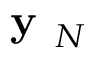<formula> <loc_0><loc_0><loc_500><loc_500>y _ { N }</formula> 